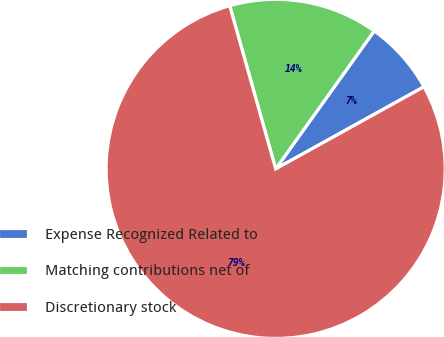Convert chart to OTSL. <chart><loc_0><loc_0><loc_500><loc_500><pie_chart><fcel>Expense Recognized Related to<fcel>Matching contributions net of<fcel>Discretionary stock<nl><fcel>7.08%<fcel>14.24%<fcel>78.67%<nl></chart> 